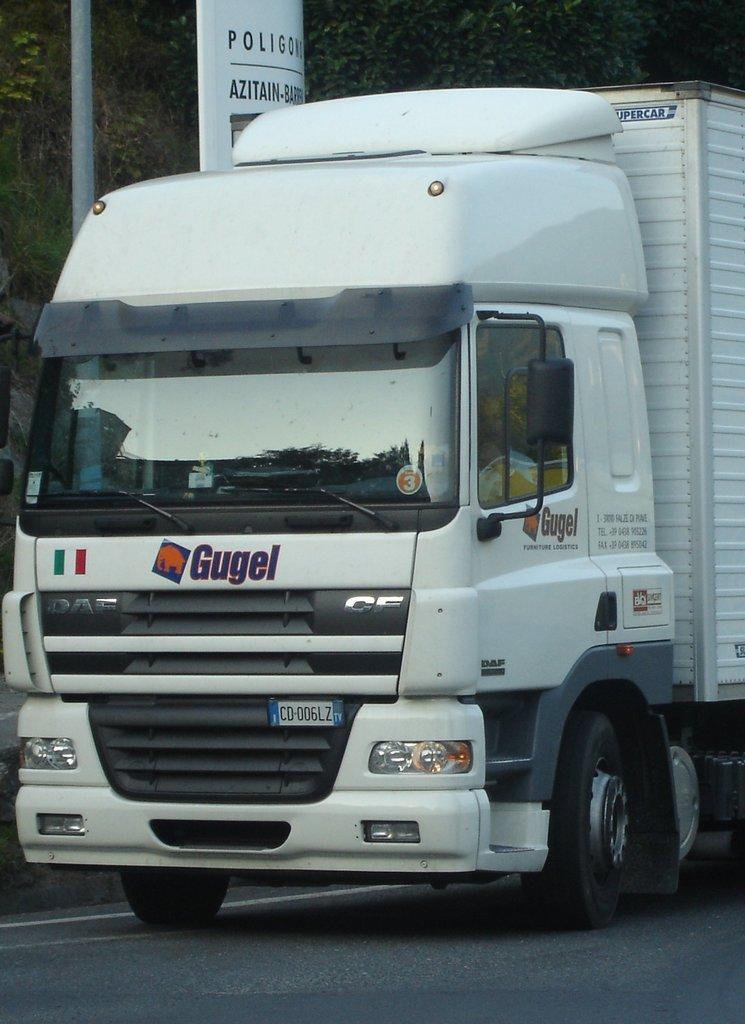How would you summarize this image in a sentence or two? In this image we can see a vehicle on the road and some text written on it, we can see the trees, text board, pole. 